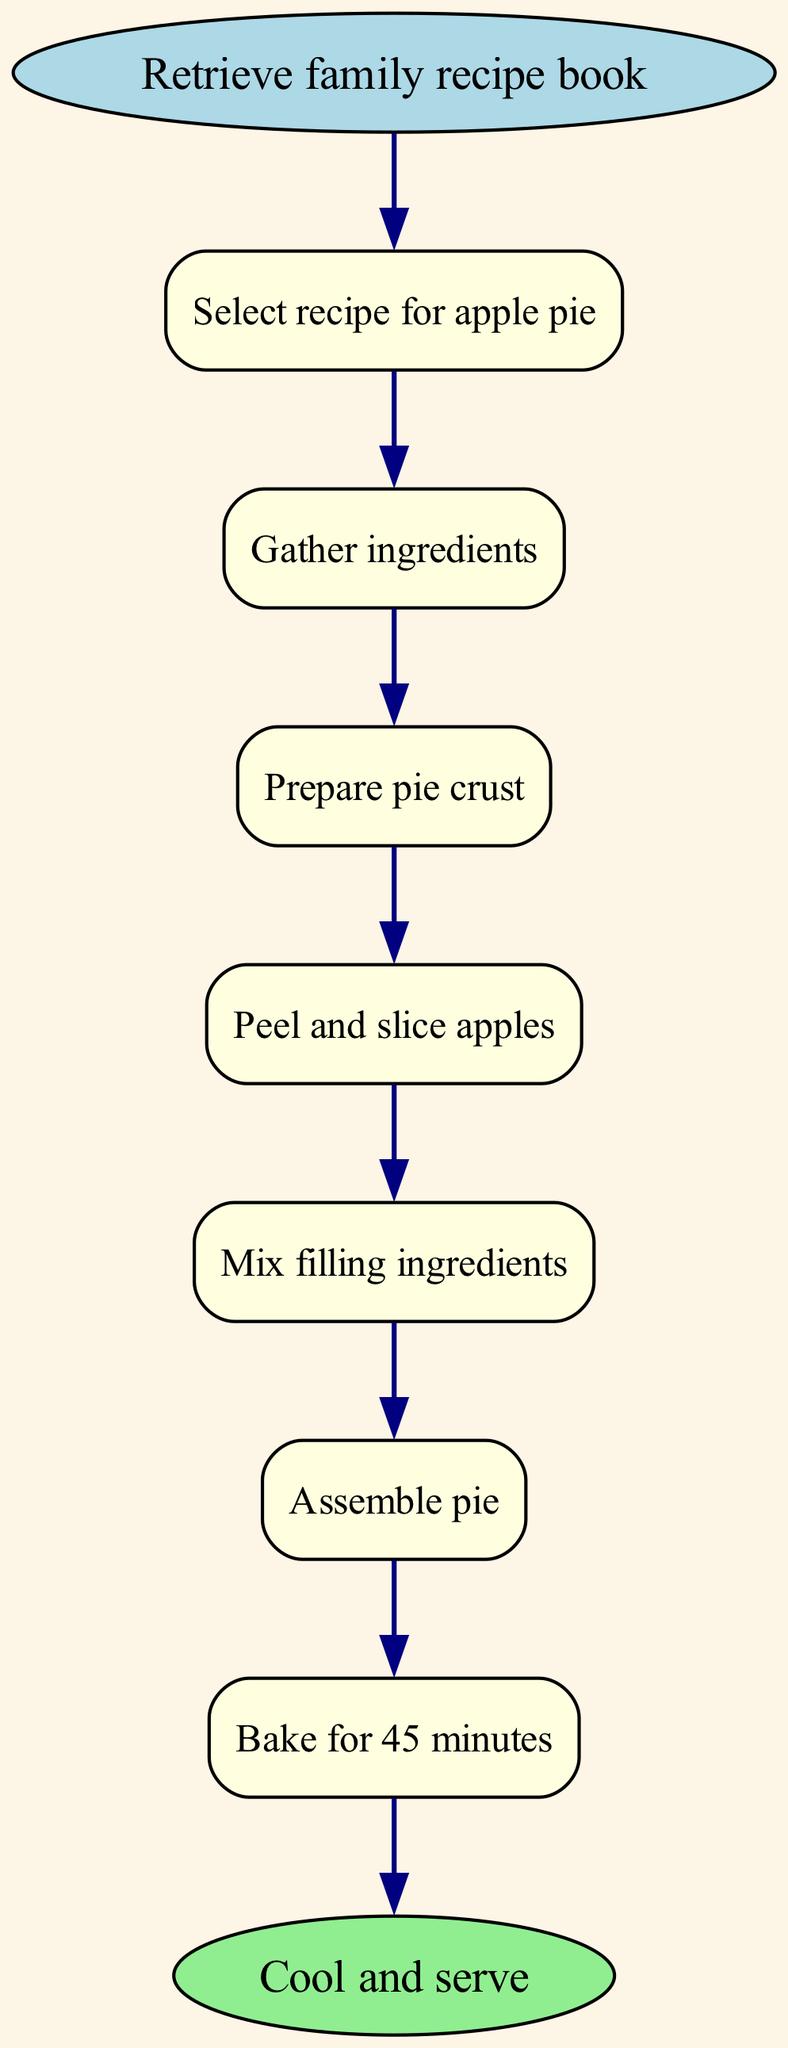What is the starting point of the flowchart? The starting point of the flowchart is identified as the "Retrieve family recipe book," which is the first node that initiates the process. It is clearly marked in the diagram as the entry point.
Answer: Retrieve family recipe book How many steps are there in total? The diagram lists seven distinct steps between the start and the end nodes. These steps are represented as individual rectangles, and by counting them, we arrive at the total of seven.
Answer: 7 What is the last action before serving the pie? The last action before serving the pie, as indicated in the flowchart, is "Bake for 45 minutes." This is the final step that must be completed in the process before the pie can be cooled and served.
Answer: Bake for 45 minutes Which step involves preparing the crust? The step that involves preparing the crust is labeled "Prepare pie crust." This specific action is shown as step 3 in the flowchart, directly indicating where the pie crust preparation fits in.
Answer: Prepare pie crust What comes after mixing filling ingredients? After "Mix filling ingredients," the next step indicated in the flowchart is "Assemble pie." This shows the progression from mixing to assembling as a necessary sequence in the recipe.
Answer: Assemble pie How do you get from gathering ingredients to peeling apples? To get from "Gather ingredients" to "Peel and slice apples," you follow the arrows connecting the nodes. The arrow leads first from gathering ingredients directly to preparing the pie crust, and then subsequently to peeling and slicing apples as the next step.
Answer: Prepare pie crust What shape represents the steps in the flowchart? The steps in the flowchart are represented by rectangles. Each step is enclosed within a rounded rectangle, which distinguishes it from the starting and ending points that are represented by ovals.
Answer: Rectangle What ingredient is specifically mentioned for preparation? The ingredient specifically mentioned for preparation in the flowchart is "apples." This is part of the process where the apples are peeled and sliced as indicated in step 4.
Answer: Apples 